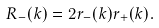Convert formula to latex. <formula><loc_0><loc_0><loc_500><loc_500>R _ { - } ( k ) = 2 r _ { - } ( k ) r _ { + } ( k ) .</formula> 